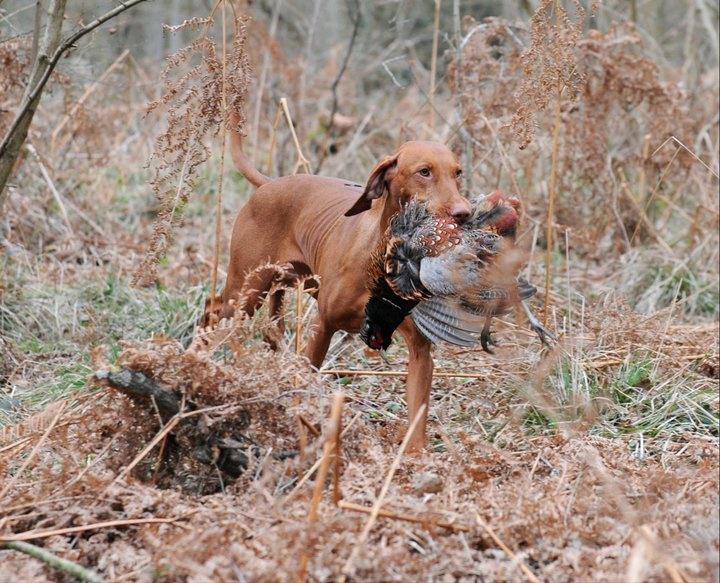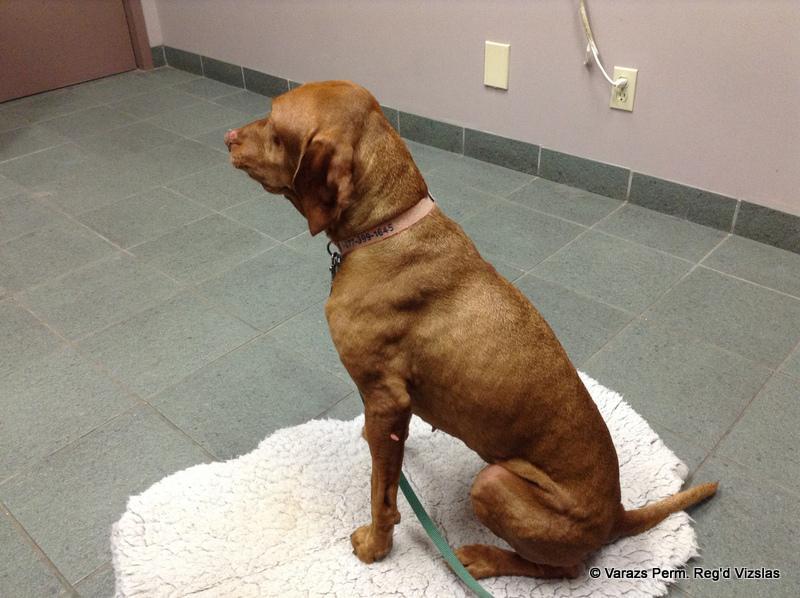The first image is the image on the left, the second image is the image on the right. For the images displayed, is the sentence "The left image features a puppy peering over a wooden ledge, and the right image includes a reclining adult dog with its head lifted to gaze upward." factually correct? Answer yes or no. No. The first image is the image on the left, the second image is the image on the right. Analyze the images presented: Is the assertion "A dog is laying down inside." valid? Answer yes or no. No. 